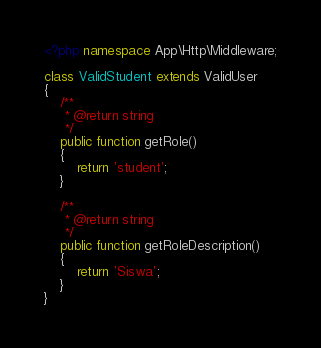<code> <loc_0><loc_0><loc_500><loc_500><_PHP_><?php namespace App\Http\Middleware;

class ValidStudent extends ValidUser
{
    /**
     * @return string
     */
    public function getRole()
    {
        return 'student';
    }

    /**
     * @return string
     */
    public function getRoleDescription()
    {
        return 'Siswa';
    }
}
</code> 